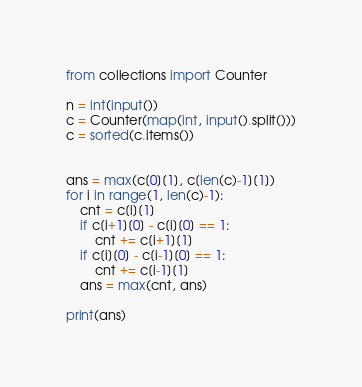<code> <loc_0><loc_0><loc_500><loc_500><_Python_>from collections import Counter

n = int(input())
c = Counter(map(int, input().split()))
c = sorted(c.items())


ans = max(c[0][1], c[len(c)-1][1])
for i in range(1, len(c)-1):
    cnt = c[i][1]
    if c[i+1][0] - c[i][0] == 1:
        cnt += c[i+1][1]
    if c[i][0] - c[i-1][0] == 1:
        cnt += c[i-1][1]
    ans = max(cnt, ans)

print(ans)
</code> 